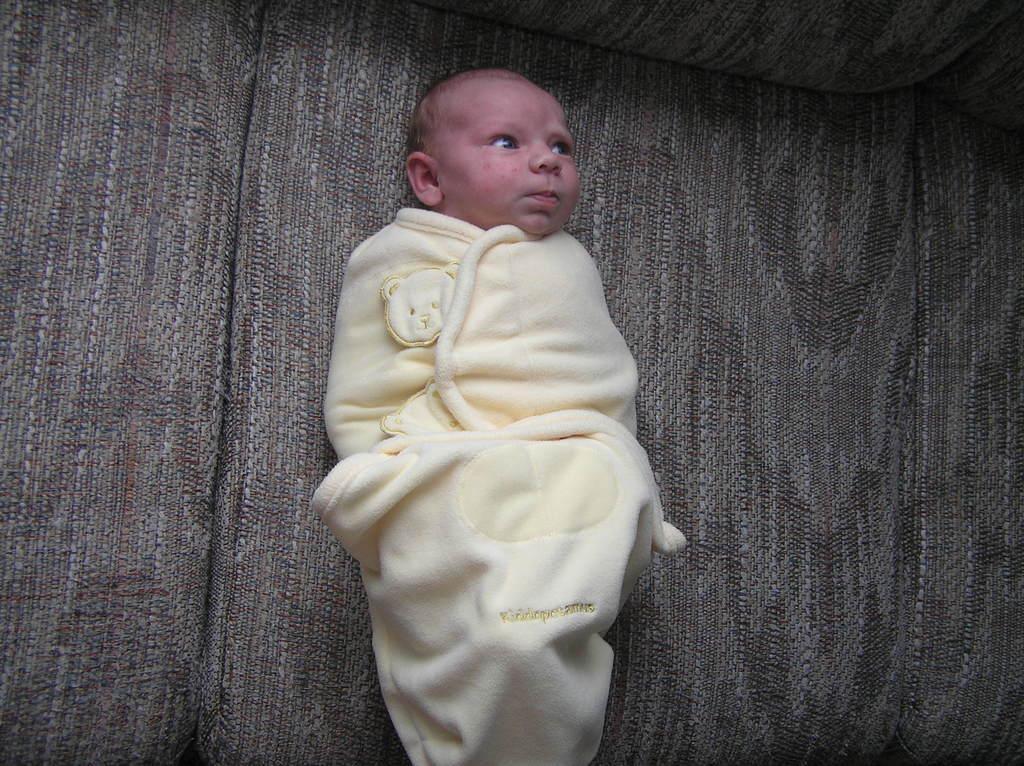How would you summarize this image in a sentence or two? This image consists of a small kid wrapped in a towel. Is sleeping on the sofa. 